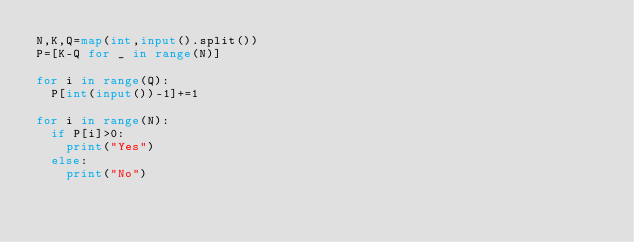<code> <loc_0><loc_0><loc_500><loc_500><_Python_>N,K,Q=map(int,input().split())
P=[K-Q for _ in range(N)]

for i in range(Q):
  P[int(input())-1]+=1

for i in range(N):
  if P[i]>0:
    print("Yes")
  else:
    print("No")</code> 